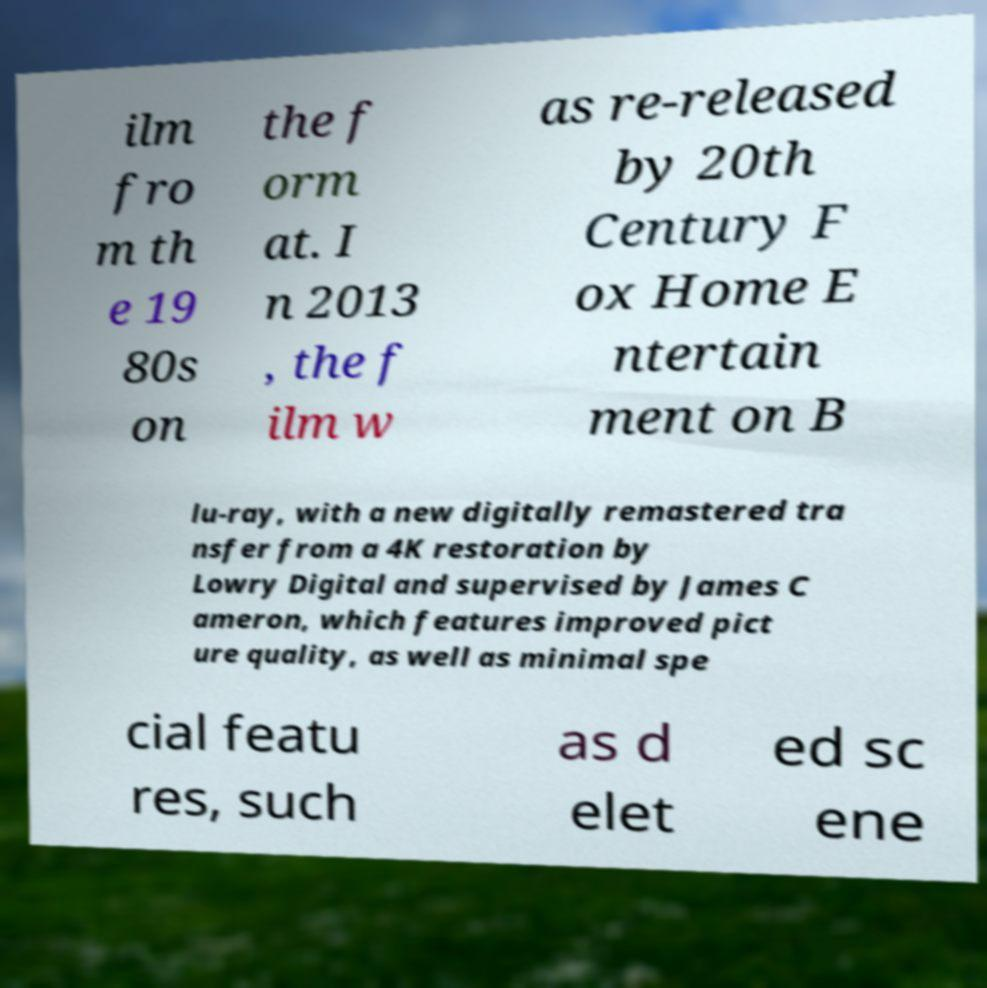Could you assist in decoding the text presented in this image and type it out clearly? ilm fro m th e 19 80s on the f orm at. I n 2013 , the f ilm w as re-released by 20th Century F ox Home E ntertain ment on B lu-ray, with a new digitally remastered tra nsfer from a 4K restoration by Lowry Digital and supervised by James C ameron, which features improved pict ure quality, as well as minimal spe cial featu res, such as d elet ed sc ene 